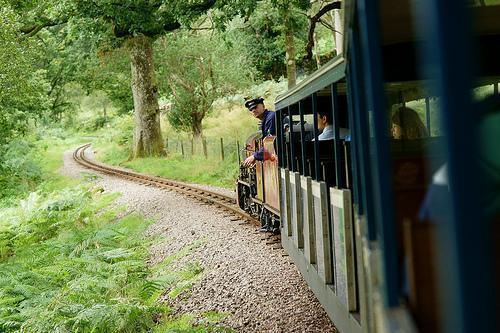How many people are standing?
Give a very brief answer. 1. 